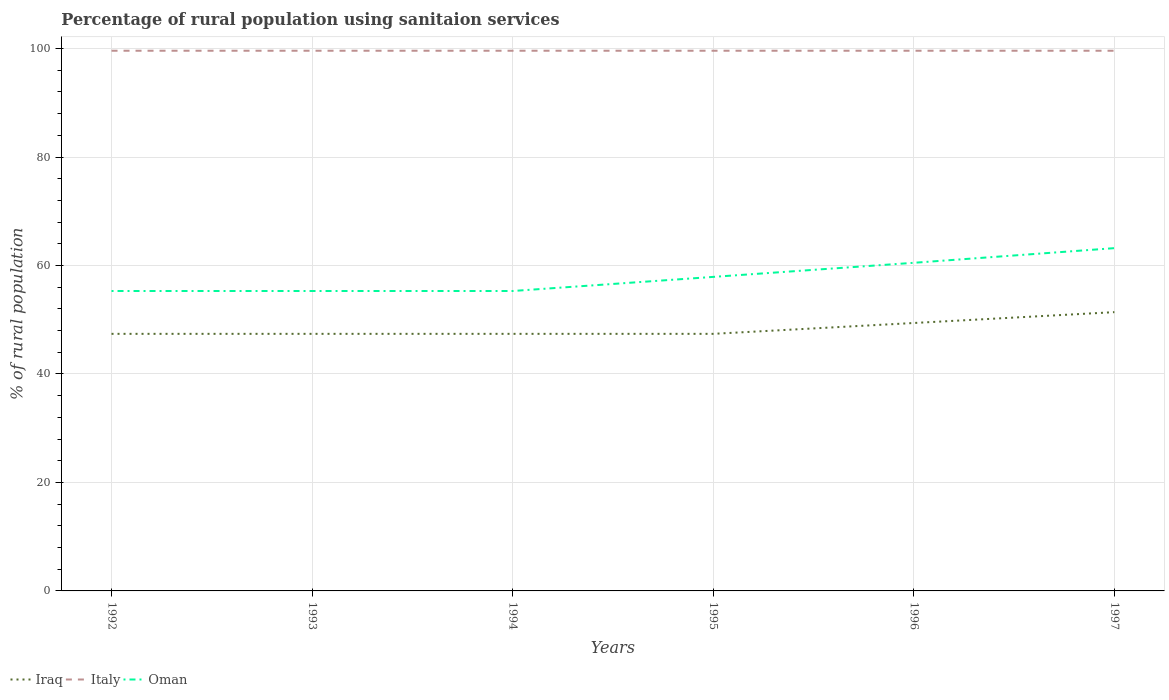How many different coloured lines are there?
Give a very brief answer. 3. Does the line corresponding to Oman intersect with the line corresponding to Iraq?
Make the answer very short. No. Is the number of lines equal to the number of legend labels?
Keep it short and to the point. Yes. Across all years, what is the maximum percentage of rural population using sanitaion services in Iraq?
Provide a short and direct response. 47.4. In which year was the percentage of rural population using sanitaion services in Italy maximum?
Your response must be concise. 1992. What is the total percentage of rural population using sanitaion services in Iraq in the graph?
Your response must be concise. -2. What is the difference between the highest and the lowest percentage of rural population using sanitaion services in Italy?
Offer a very short reply. 0. Is the percentage of rural population using sanitaion services in Oman strictly greater than the percentage of rural population using sanitaion services in Italy over the years?
Offer a terse response. Yes. What is the difference between two consecutive major ticks on the Y-axis?
Provide a short and direct response. 20. How many legend labels are there?
Offer a terse response. 3. How are the legend labels stacked?
Offer a terse response. Horizontal. What is the title of the graph?
Ensure brevity in your answer.  Percentage of rural population using sanitaion services. What is the label or title of the X-axis?
Ensure brevity in your answer.  Years. What is the label or title of the Y-axis?
Provide a succinct answer. % of rural population. What is the % of rural population in Iraq in 1992?
Your answer should be compact. 47.4. What is the % of rural population in Italy in 1992?
Ensure brevity in your answer.  99.6. What is the % of rural population of Oman in 1992?
Offer a terse response. 55.3. What is the % of rural population in Iraq in 1993?
Provide a short and direct response. 47.4. What is the % of rural population in Italy in 1993?
Offer a very short reply. 99.6. What is the % of rural population in Oman in 1993?
Provide a short and direct response. 55.3. What is the % of rural population in Iraq in 1994?
Your answer should be very brief. 47.4. What is the % of rural population in Italy in 1994?
Provide a short and direct response. 99.6. What is the % of rural population of Oman in 1994?
Offer a very short reply. 55.3. What is the % of rural population in Iraq in 1995?
Give a very brief answer. 47.4. What is the % of rural population in Italy in 1995?
Give a very brief answer. 99.6. What is the % of rural population of Oman in 1995?
Provide a succinct answer. 57.9. What is the % of rural population of Iraq in 1996?
Keep it short and to the point. 49.4. What is the % of rural population in Italy in 1996?
Provide a short and direct response. 99.6. What is the % of rural population of Oman in 1996?
Offer a terse response. 60.5. What is the % of rural population of Iraq in 1997?
Your response must be concise. 51.4. What is the % of rural population of Italy in 1997?
Your response must be concise. 99.6. What is the % of rural population of Oman in 1997?
Make the answer very short. 63.2. Across all years, what is the maximum % of rural population in Iraq?
Keep it short and to the point. 51.4. Across all years, what is the maximum % of rural population of Italy?
Your response must be concise. 99.6. Across all years, what is the maximum % of rural population of Oman?
Provide a succinct answer. 63.2. Across all years, what is the minimum % of rural population in Iraq?
Offer a very short reply. 47.4. Across all years, what is the minimum % of rural population of Italy?
Offer a very short reply. 99.6. Across all years, what is the minimum % of rural population of Oman?
Your response must be concise. 55.3. What is the total % of rural population in Iraq in the graph?
Offer a very short reply. 290.4. What is the total % of rural population in Italy in the graph?
Provide a short and direct response. 597.6. What is the total % of rural population in Oman in the graph?
Ensure brevity in your answer.  347.5. What is the difference between the % of rural population of Iraq in 1992 and that in 1993?
Your response must be concise. 0. What is the difference between the % of rural population of Italy in 1992 and that in 1993?
Your answer should be compact. 0. What is the difference between the % of rural population of Oman in 1992 and that in 1993?
Your answer should be very brief. 0. What is the difference between the % of rural population of Iraq in 1992 and that in 1994?
Your answer should be compact. 0. What is the difference between the % of rural population in Italy in 1992 and that in 1994?
Provide a short and direct response. 0. What is the difference between the % of rural population in Italy in 1992 and that in 1995?
Your answer should be compact. 0. What is the difference between the % of rural population of Oman in 1992 and that in 1995?
Your response must be concise. -2.6. What is the difference between the % of rural population of Iraq in 1992 and that in 1997?
Your response must be concise. -4. What is the difference between the % of rural population in Oman in 1993 and that in 1994?
Make the answer very short. 0. What is the difference between the % of rural population of Iraq in 1993 and that in 1995?
Make the answer very short. 0. What is the difference between the % of rural population in Italy in 1993 and that in 1995?
Your answer should be compact. 0. What is the difference between the % of rural population in Oman in 1993 and that in 1995?
Give a very brief answer. -2.6. What is the difference between the % of rural population of Italy in 1993 and that in 1996?
Offer a terse response. 0. What is the difference between the % of rural population of Iraq in 1993 and that in 1997?
Ensure brevity in your answer.  -4. What is the difference between the % of rural population in Italy in 1994 and that in 1995?
Make the answer very short. 0. What is the difference between the % of rural population of Oman in 1994 and that in 1995?
Offer a terse response. -2.6. What is the difference between the % of rural population in Italy in 1994 and that in 1996?
Provide a short and direct response. 0. What is the difference between the % of rural population in Oman in 1994 and that in 1996?
Your answer should be very brief. -5.2. What is the difference between the % of rural population of Iraq in 1994 and that in 1997?
Give a very brief answer. -4. What is the difference between the % of rural population of Italy in 1995 and that in 1996?
Give a very brief answer. 0. What is the difference between the % of rural population of Oman in 1995 and that in 1997?
Offer a terse response. -5.3. What is the difference between the % of rural population of Iraq in 1996 and that in 1997?
Provide a short and direct response. -2. What is the difference between the % of rural population of Italy in 1996 and that in 1997?
Provide a short and direct response. 0. What is the difference between the % of rural population in Iraq in 1992 and the % of rural population in Italy in 1993?
Ensure brevity in your answer.  -52.2. What is the difference between the % of rural population in Iraq in 1992 and the % of rural population in Oman in 1993?
Your response must be concise. -7.9. What is the difference between the % of rural population in Italy in 1992 and the % of rural population in Oman in 1993?
Offer a terse response. 44.3. What is the difference between the % of rural population in Iraq in 1992 and the % of rural population in Italy in 1994?
Provide a succinct answer. -52.2. What is the difference between the % of rural population in Iraq in 1992 and the % of rural population in Oman in 1994?
Ensure brevity in your answer.  -7.9. What is the difference between the % of rural population of Italy in 1992 and the % of rural population of Oman in 1994?
Your response must be concise. 44.3. What is the difference between the % of rural population in Iraq in 1992 and the % of rural population in Italy in 1995?
Offer a terse response. -52.2. What is the difference between the % of rural population in Italy in 1992 and the % of rural population in Oman in 1995?
Ensure brevity in your answer.  41.7. What is the difference between the % of rural population in Iraq in 1992 and the % of rural population in Italy in 1996?
Offer a very short reply. -52.2. What is the difference between the % of rural population in Iraq in 1992 and the % of rural population in Oman in 1996?
Give a very brief answer. -13.1. What is the difference between the % of rural population of Italy in 1992 and the % of rural population of Oman in 1996?
Keep it short and to the point. 39.1. What is the difference between the % of rural population in Iraq in 1992 and the % of rural population in Italy in 1997?
Make the answer very short. -52.2. What is the difference between the % of rural population in Iraq in 1992 and the % of rural population in Oman in 1997?
Your response must be concise. -15.8. What is the difference between the % of rural population in Italy in 1992 and the % of rural population in Oman in 1997?
Ensure brevity in your answer.  36.4. What is the difference between the % of rural population of Iraq in 1993 and the % of rural population of Italy in 1994?
Give a very brief answer. -52.2. What is the difference between the % of rural population of Iraq in 1993 and the % of rural population of Oman in 1994?
Your answer should be compact. -7.9. What is the difference between the % of rural population of Italy in 1993 and the % of rural population of Oman in 1994?
Keep it short and to the point. 44.3. What is the difference between the % of rural population in Iraq in 1993 and the % of rural population in Italy in 1995?
Your response must be concise. -52.2. What is the difference between the % of rural population of Iraq in 1993 and the % of rural population of Oman in 1995?
Offer a very short reply. -10.5. What is the difference between the % of rural population in Italy in 1993 and the % of rural population in Oman in 1995?
Ensure brevity in your answer.  41.7. What is the difference between the % of rural population in Iraq in 1993 and the % of rural population in Italy in 1996?
Ensure brevity in your answer.  -52.2. What is the difference between the % of rural population of Italy in 1993 and the % of rural population of Oman in 1996?
Your answer should be very brief. 39.1. What is the difference between the % of rural population in Iraq in 1993 and the % of rural population in Italy in 1997?
Ensure brevity in your answer.  -52.2. What is the difference between the % of rural population of Iraq in 1993 and the % of rural population of Oman in 1997?
Provide a short and direct response. -15.8. What is the difference between the % of rural population in Italy in 1993 and the % of rural population in Oman in 1997?
Provide a succinct answer. 36.4. What is the difference between the % of rural population of Iraq in 1994 and the % of rural population of Italy in 1995?
Offer a very short reply. -52.2. What is the difference between the % of rural population of Iraq in 1994 and the % of rural population of Oman in 1995?
Provide a short and direct response. -10.5. What is the difference between the % of rural population of Italy in 1994 and the % of rural population of Oman in 1995?
Provide a succinct answer. 41.7. What is the difference between the % of rural population of Iraq in 1994 and the % of rural population of Italy in 1996?
Offer a very short reply. -52.2. What is the difference between the % of rural population of Italy in 1994 and the % of rural population of Oman in 1996?
Your answer should be very brief. 39.1. What is the difference between the % of rural population of Iraq in 1994 and the % of rural population of Italy in 1997?
Provide a succinct answer. -52.2. What is the difference between the % of rural population in Iraq in 1994 and the % of rural population in Oman in 1997?
Your answer should be very brief. -15.8. What is the difference between the % of rural population of Italy in 1994 and the % of rural population of Oman in 1997?
Your response must be concise. 36.4. What is the difference between the % of rural population in Iraq in 1995 and the % of rural population in Italy in 1996?
Provide a short and direct response. -52.2. What is the difference between the % of rural population in Italy in 1995 and the % of rural population in Oman in 1996?
Give a very brief answer. 39.1. What is the difference between the % of rural population in Iraq in 1995 and the % of rural population in Italy in 1997?
Offer a terse response. -52.2. What is the difference between the % of rural population in Iraq in 1995 and the % of rural population in Oman in 1997?
Your response must be concise. -15.8. What is the difference between the % of rural population of Italy in 1995 and the % of rural population of Oman in 1997?
Ensure brevity in your answer.  36.4. What is the difference between the % of rural population of Iraq in 1996 and the % of rural population of Italy in 1997?
Your answer should be very brief. -50.2. What is the difference between the % of rural population in Italy in 1996 and the % of rural population in Oman in 1997?
Provide a short and direct response. 36.4. What is the average % of rural population of Iraq per year?
Your answer should be very brief. 48.4. What is the average % of rural population in Italy per year?
Provide a short and direct response. 99.6. What is the average % of rural population of Oman per year?
Offer a terse response. 57.92. In the year 1992, what is the difference between the % of rural population in Iraq and % of rural population in Italy?
Your response must be concise. -52.2. In the year 1992, what is the difference between the % of rural population of Italy and % of rural population of Oman?
Provide a succinct answer. 44.3. In the year 1993, what is the difference between the % of rural population of Iraq and % of rural population of Italy?
Ensure brevity in your answer.  -52.2. In the year 1993, what is the difference between the % of rural population of Italy and % of rural population of Oman?
Your answer should be compact. 44.3. In the year 1994, what is the difference between the % of rural population in Iraq and % of rural population in Italy?
Offer a very short reply. -52.2. In the year 1994, what is the difference between the % of rural population in Italy and % of rural population in Oman?
Your answer should be compact. 44.3. In the year 1995, what is the difference between the % of rural population in Iraq and % of rural population in Italy?
Your answer should be very brief. -52.2. In the year 1995, what is the difference between the % of rural population of Iraq and % of rural population of Oman?
Keep it short and to the point. -10.5. In the year 1995, what is the difference between the % of rural population in Italy and % of rural population in Oman?
Your answer should be very brief. 41.7. In the year 1996, what is the difference between the % of rural population in Iraq and % of rural population in Italy?
Provide a short and direct response. -50.2. In the year 1996, what is the difference between the % of rural population of Iraq and % of rural population of Oman?
Your answer should be very brief. -11.1. In the year 1996, what is the difference between the % of rural population in Italy and % of rural population in Oman?
Make the answer very short. 39.1. In the year 1997, what is the difference between the % of rural population of Iraq and % of rural population of Italy?
Make the answer very short. -48.2. In the year 1997, what is the difference between the % of rural population in Iraq and % of rural population in Oman?
Give a very brief answer. -11.8. In the year 1997, what is the difference between the % of rural population in Italy and % of rural population in Oman?
Make the answer very short. 36.4. What is the ratio of the % of rural population of Iraq in 1992 to that in 1993?
Ensure brevity in your answer.  1. What is the ratio of the % of rural population of Iraq in 1992 to that in 1994?
Offer a terse response. 1. What is the ratio of the % of rural population of Italy in 1992 to that in 1995?
Offer a terse response. 1. What is the ratio of the % of rural population of Oman in 1992 to that in 1995?
Your answer should be compact. 0.96. What is the ratio of the % of rural population of Iraq in 1992 to that in 1996?
Your response must be concise. 0.96. What is the ratio of the % of rural population of Oman in 1992 to that in 1996?
Ensure brevity in your answer.  0.91. What is the ratio of the % of rural population of Iraq in 1992 to that in 1997?
Offer a terse response. 0.92. What is the ratio of the % of rural population of Iraq in 1993 to that in 1994?
Offer a terse response. 1. What is the ratio of the % of rural population of Oman in 1993 to that in 1994?
Your answer should be very brief. 1. What is the ratio of the % of rural population in Italy in 1993 to that in 1995?
Your answer should be very brief. 1. What is the ratio of the % of rural population of Oman in 1993 to that in 1995?
Offer a very short reply. 0.96. What is the ratio of the % of rural population of Iraq in 1993 to that in 1996?
Ensure brevity in your answer.  0.96. What is the ratio of the % of rural population in Italy in 1993 to that in 1996?
Ensure brevity in your answer.  1. What is the ratio of the % of rural population of Oman in 1993 to that in 1996?
Give a very brief answer. 0.91. What is the ratio of the % of rural population in Iraq in 1993 to that in 1997?
Keep it short and to the point. 0.92. What is the ratio of the % of rural population in Italy in 1993 to that in 1997?
Keep it short and to the point. 1. What is the ratio of the % of rural population in Italy in 1994 to that in 1995?
Provide a short and direct response. 1. What is the ratio of the % of rural population of Oman in 1994 to that in 1995?
Provide a short and direct response. 0.96. What is the ratio of the % of rural population of Iraq in 1994 to that in 1996?
Make the answer very short. 0.96. What is the ratio of the % of rural population in Oman in 1994 to that in 1996?
Give a very brief answer. 0.91. What is the ratio of the % of rural population in Iraq in 1994 to that in 1997?
Your answer should be very brief. 0.92. What is the ratio of the % of rural population of Oman in 1994 to that in 1997?
Offer a very short reply. 0.88. What is the ratio of the % of rural population of Iraq in 1995 to that in 1996?
Make the answer very short. 0.96. What is the ratio of the % of rural population of Iraq in 1995 to that in 1997?
Your answer should be very brief. 0.92. What is the ratio of the % of rural population in Oman in 1995 to that in 1997?
Ensure brevity in your answer.  0.92. What is the ratio of the % of rural population of Iraq in 1996 to that in 1997?
Provide a succinct answer. 0.96. What is the ratio of the % of rural population in Oman in 1996 to that in 1997?
Offer a terse response. 0.96. What is the difference between the highest and the second highest % of rural population of Iraq?
Your answer should be compact. 2. What is the difference between the highest and the second highest % of rural population in Oman?
Provide a succinct answer. 2.7. What is the difference between the highest and the lowest % of rural population in Iraq?
Ensure brevity in your answer.  4. What is the difference between the highest and the lowest % of rural population of Italy?
Offer a very short reply. 0. What is the difference between the highest and the lowest % of rural population of Oman?
Offer a terse response. 7.9. 